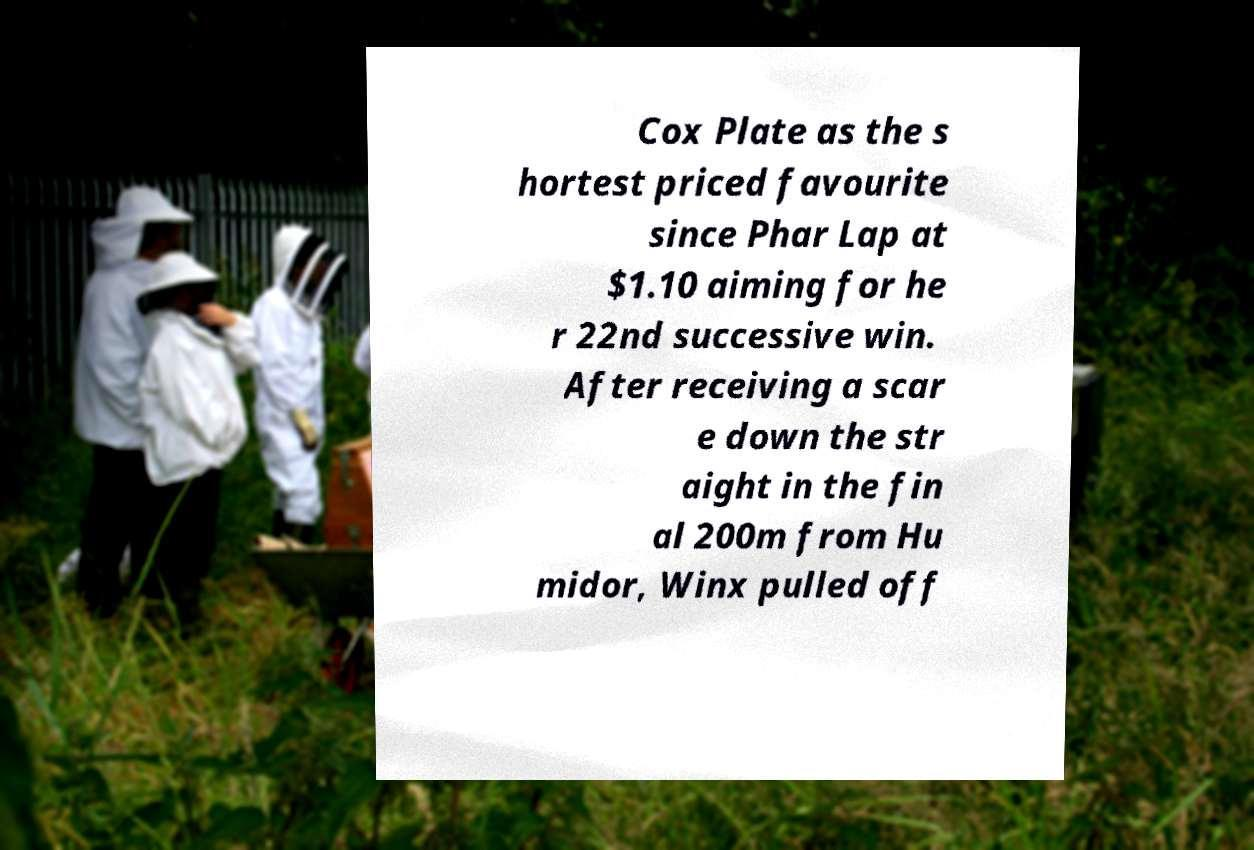What messages or text are displayed in this image? I need them in a readable, typed format. Cox Plate as the s hortest priced favourite since Phar Lap at $1.10 aiming for he r 22nd successive win. After receiving a scar e down the str aight in the fin al 200m from Hu midor, Winx pulled off 